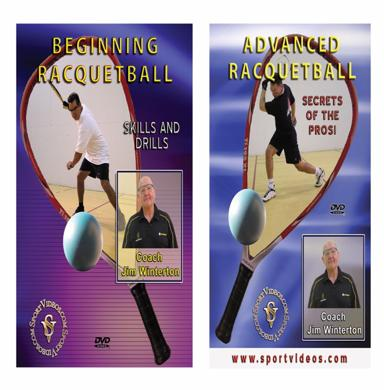Could you tell me more about the instructor featured in these DVDs? Certainly! The DVDs feature Coach Jim Winterton, a well-respected figure in the racquetball community with decades of coaching experience. He is known for his detailed and methodical approach to training, helping players at all levels improve their skills effectively. His expert insights are invaluable for anyone serious about advancing their racquetball game. 